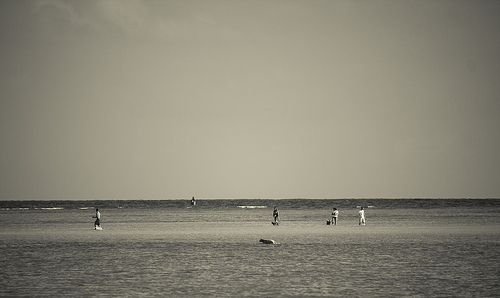[0.71, 0.61, 0.73, 0.67]. A man dressed in a casual white t-shirt is captured in this sector of the image, lending a relaxed and leisurely atmosphere to the beach setting. 